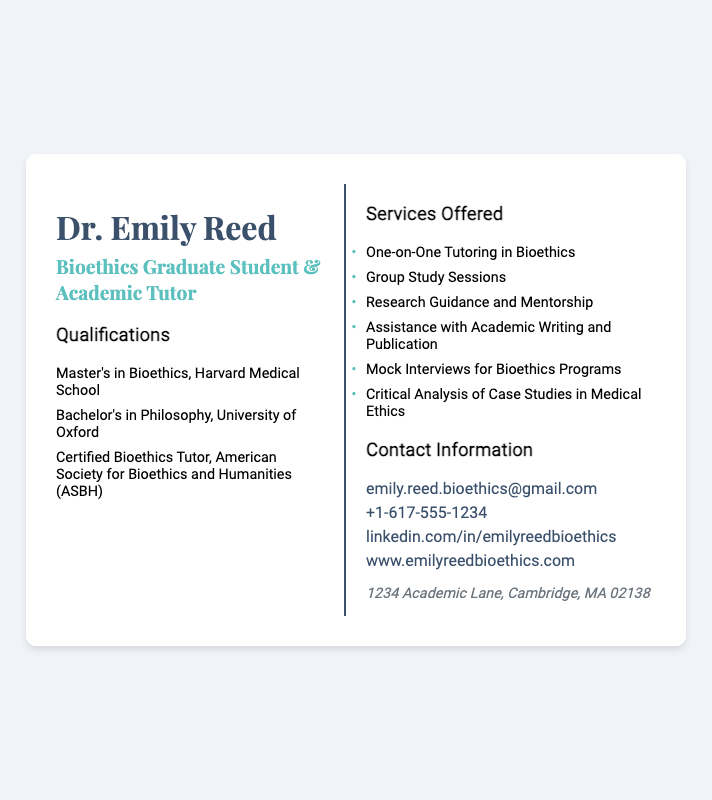What is the name of the academic tutor? The name is prominently displayed at the top of the card.
Answer: Dr. Emily Reed What degree did Dr. Emily Reed earn from Harvard Medical School? This is mentioned in the qualifications section of the card.
Answer: Master's in Bioethics What type of tutoring does Dr. Emily Reed offer? This is specified in the services offered section of the card.
Answer: One-on-One Tutoring in Bioethics How many qualifications are listed in total? Each qualification is itemized in the qualifications section.
Answer: Three What contact method is provided for emailing Dr. Emily Reed? This information is found in the contact information section of the card.
Answer: emily.reed.bioethics@gmail.com Which university did Dr. Emily Reed attend for her Bachelor's degree? This information is included in the qualifications portion of the card.
Answer: University of Oxford What is the phone number listed on the card? This is found in the contact information section.
Answer: +1-617-555-1234 What type of sessions does Dr. Emily Reed offer besides one-on-one tutoring? This involves reasoning through the services listed on the card.
Answer: Group Study Sessions Where is Dr. Emily Reed's office located? This information is provided in the contact section of the card.
Answer: 1234 Academic Lane, Cambridge, MA 02138 